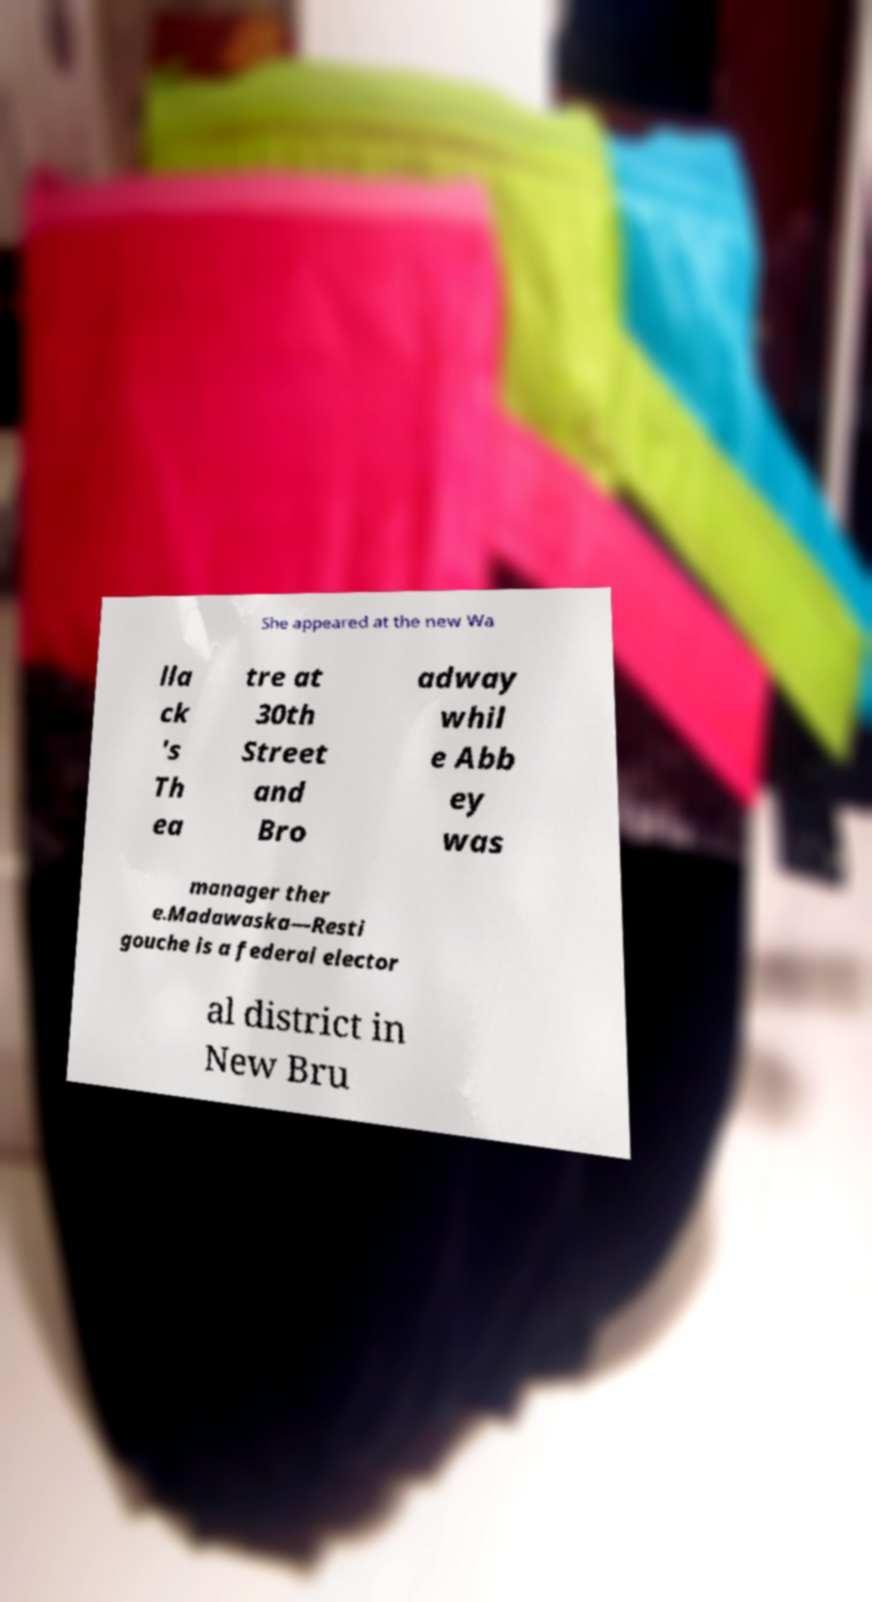Could you extract and type out the text from this image? She appeared at the new Wa lla ck 's Th ea tre at 30th Street and Bro adway whil e Abb ey was manager ther e.Madawaska—Resti gouche is a federal elector al district in New Bru 